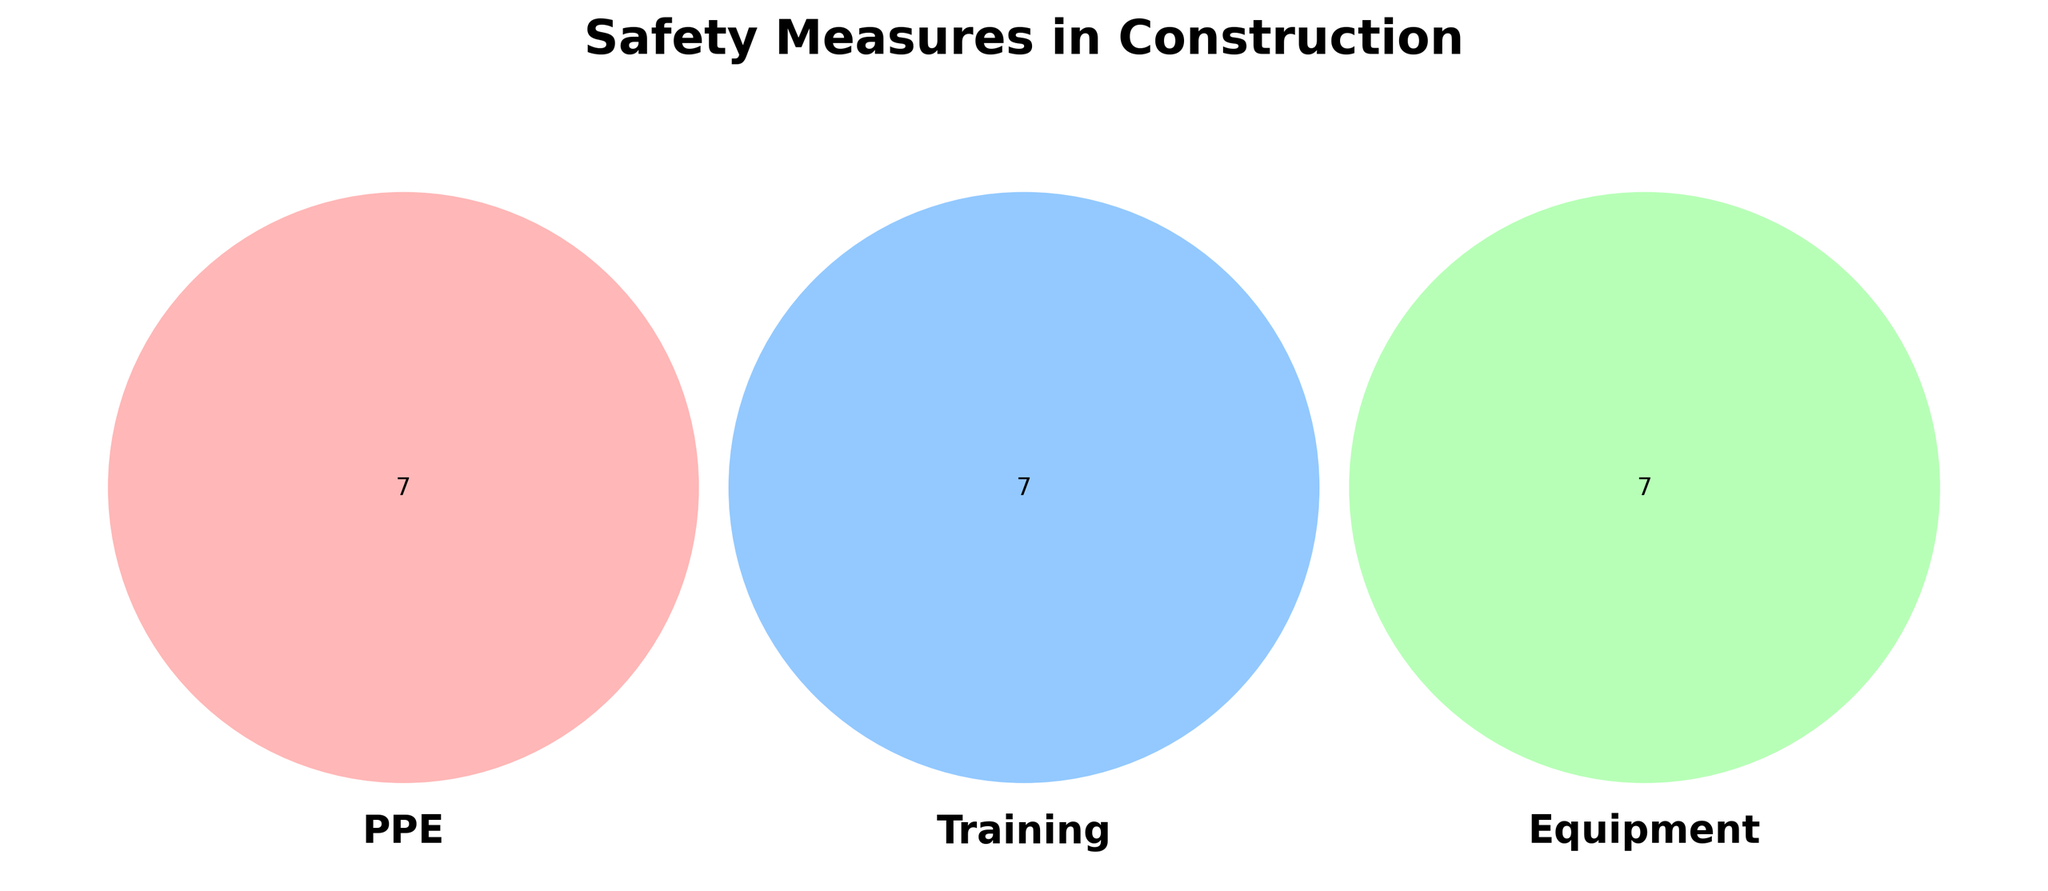What are the three components listed in the Venn diagram? Looking at the figure, the components are titles representing the categories of safety measures.
Answer: PPE, Training, Equipment How many elements are exclusive to PPE? Identify and count the elements in the section of the Venn diagram that only intersects with PPE.
Answer: 7 Which safety measure categories intersect with Training and Equipment but not PPE? Check the section where Training and Equipment overlap while ensuring it doesn't intersect PPE.
Answer: None What are the common items between PPE and Training? Look at the overlapping region between PPE and Training to list the elements.
Answer: None Which category has the item "Excavators"? Locate "Excavators" in the Venn diagram and identify its corresponding category.
Answer: Equipment Are there any common items between PPE and Equipment categories? Examine if there's any overlapping region between PPE and Equipment.
Answer: No Which safety measure categories show "Fall protection training"? Find "Fall protection training" and identify its respective category.
Answer: Training Is there a category that intersects all three: PPE, Training, and Equipment? Check if there is a section where all three categories overlap.
Answer: No 